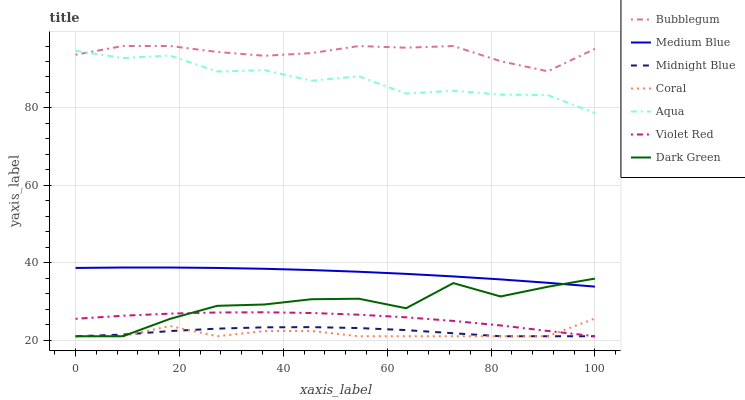Does Coral have the minimum area under the curve?
Answer yes or no. Yes. Does Bubblegum have the maximum area under the curve?
Answer yes or no. Yes. Does Midnight Blue have the minimum area under the curve?
Answer yes or no. No. Does Midnight Blue have the maximum area under the curve?
Answer yes or no. No. Is Medium Blue the smoothest?
Answer yes or no. Yes. Is Dark Green the roughest?
Answer yes or no. Yes. Is Midnight Blue the smoothest?
Answer yes or no. No. Is Midnight Blue the roughest?
Answer yes or no. No. Does Violet Red have the lowest value?
Answer yes or no. Yes. Does Medium Blue have the lowest value?
Answer yes or no. No. Does Bubblegum have the highest value?
Answer yes or no. Yes. Does Medium Blue have the highest value?
Answer yes or no. No. Is Coral less than Bubblegum?
Answer yes or no. Yes. Is Medium Blue greater than Midnight Blue?
Answer yes or no. Yes. Does Midnight Blue intersect Dark Green?
Answer yes or no. Yes. Is Midnight Blue less than Dark Green?
Answer yes or no. No. Is Midnight Blue greater than Dark Green?
Answer yes or no. No. Does Coral intersect Bubblegum?
Answer yes or no. No. 